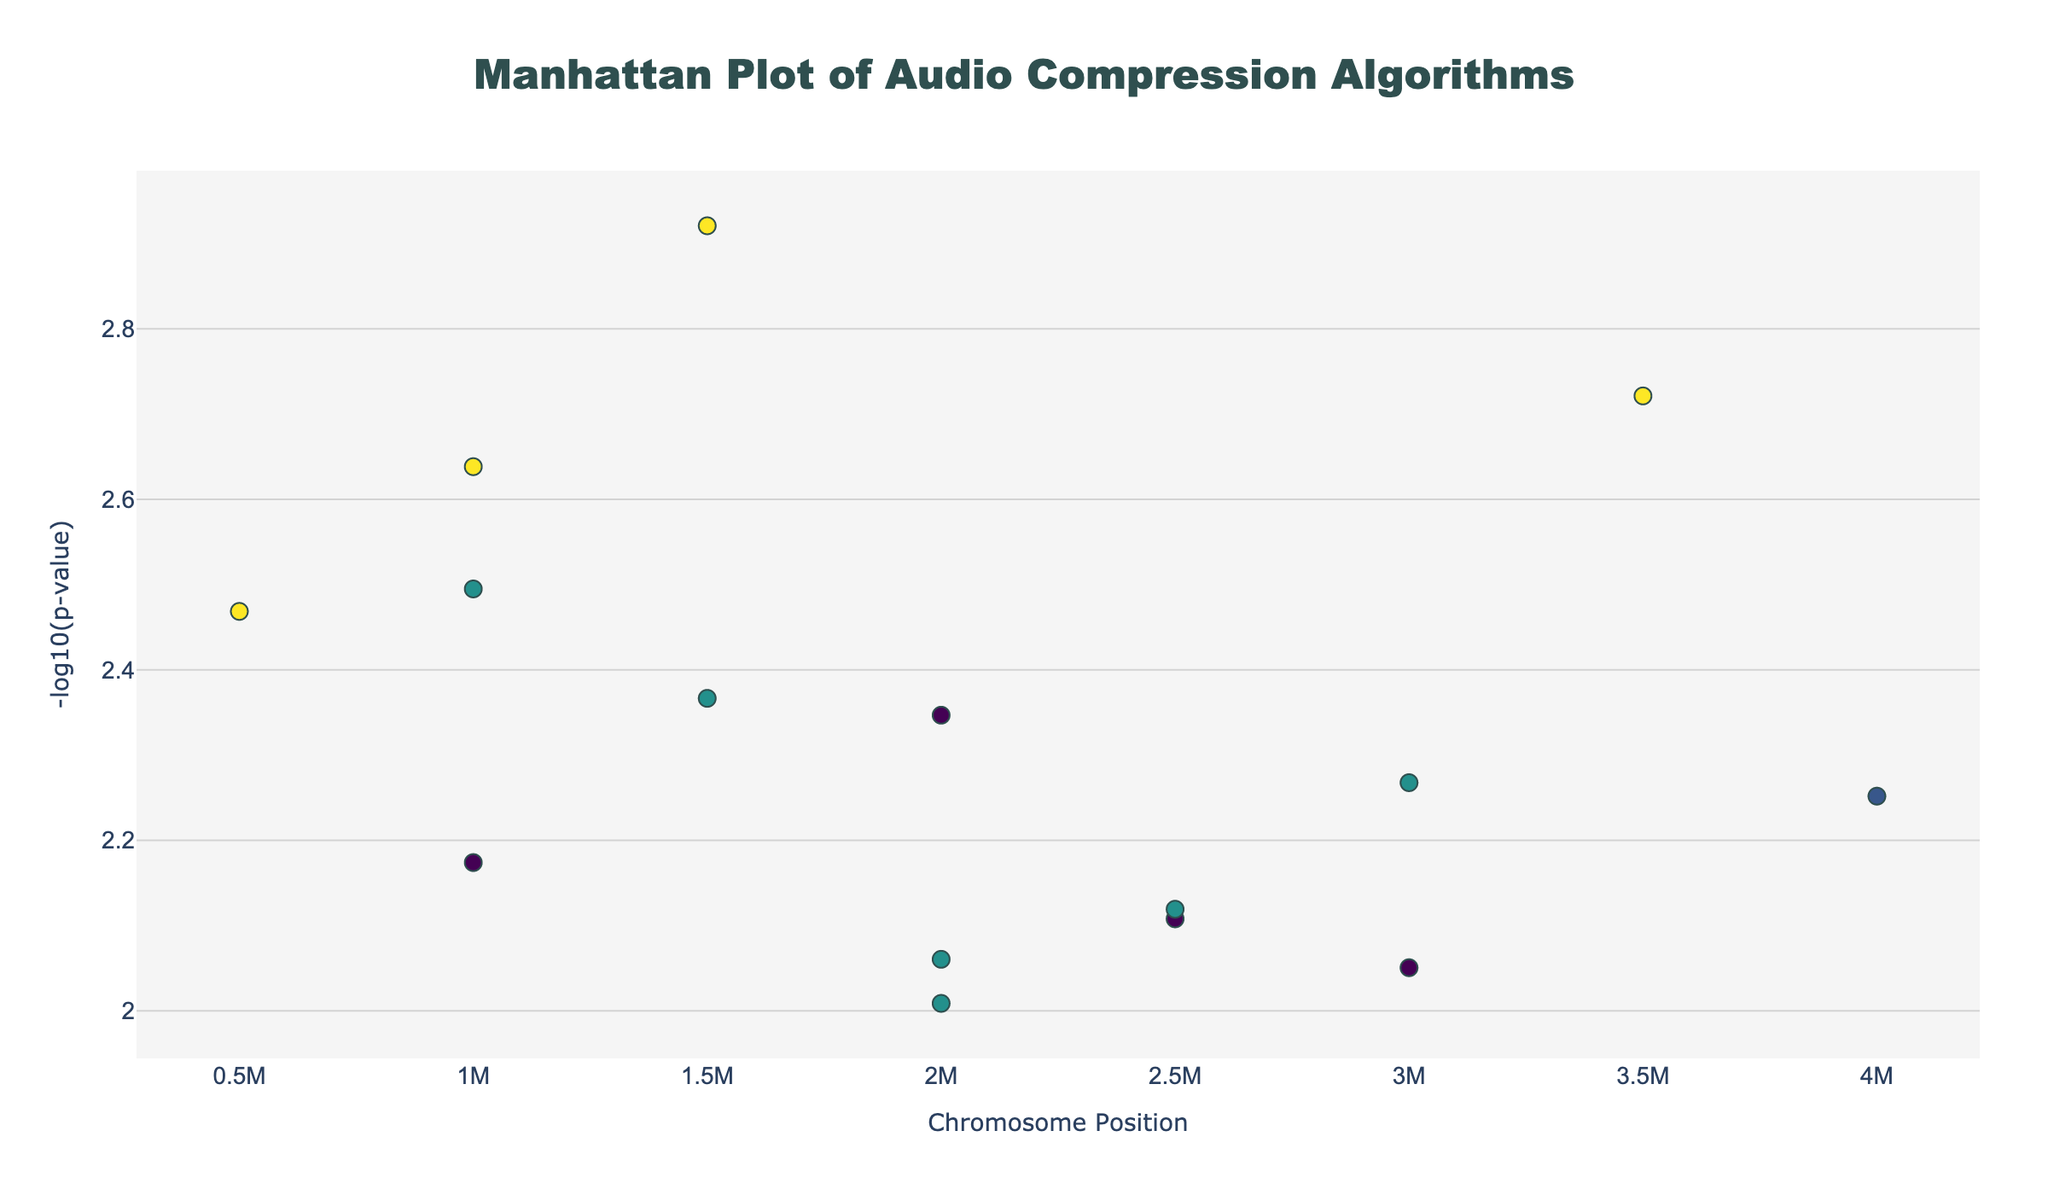What's the title of the plot? The title of the plot is displayed at the top center. It helps in understanding the main subject of the plot.
Answer: Manhattan Plot of Audio Compression Algorithms What does the y-axis represent? The y-axis represents the -log10(p-value), indicating the statistical significance of the data points. Higher values correspond to lower p-values or more statistically significant results.
Answer: -log10(p-value) Which audio compression algorithm has the highest statistical significance on Chromosome 4? On Chromosome 4, the algorithm with the highest -log10(p-value) is ALAC, visible as it appears as one of the highest points.
Answer: ALAC What is the position of the AAC algorithm on Chromosome 1? The position of the AAC algorithm is found by looking at the tooltip information for points on Chromosome 1. AAC corresponds to the x-axis value for position.
Answer: 1000000 How many data points are from Chromosome 5? By observing the legend or the scatter plot, you can count the number of points corresponding to Chromosome 5, which is one point.
Answer: 1 Which chromosome shows the least statistically significant data point? The least statistically significant data point is determined by finding the lowest value on the y-axis, indicating the highest p-value. Chromosome 5 has the lowest point.
Answer: Chromosome 5 What's the average statistical significance (-log10(p-value)) of the data points on Chromosome 1? Calculate the -log10(p-value) for data points on Chromosome 1, sum them up, and divide by the number of points: (-log10(0.0023) + -log10(0.0078) + -log10(0.0056))/3 ≈ (2.638 + 2.108 + 2.252)/3 ≈ 2.333
Answer: 2.333 Compare the significance of algorithms on Chromosome 2. Which one has a lower p-value, Vorbis or FLAC? Compare the -log10(p-values) of Vorbis and FLAC on Chromosome 2. The higher -log10(p-value) indicates a lower p-value. Vorbis (-log10(0.0012) = 2.920) is more significant than FLAC (-log10(0.0089) = 2.051).
Answer: Vorbis What is the color of the point representing the AC3 algorithm? The color can be identified by viewing the colorscale mapped to -log10(p) for the point representing the AC3 algorithm. It's on Chromosome 4 with -log10(p-value) around 2.721, within the colorscale Viridis.
Answer: Dark green Which chromosome has the most diverse spread of -log10(p-values)? Evaluate the spread of values along the y-axis for each chromosome to identify diversity. Chromosome 1, having multiple distinct points with varying -log10(p-values), shows the most diverse spread.
Answer: Chromosome 1 